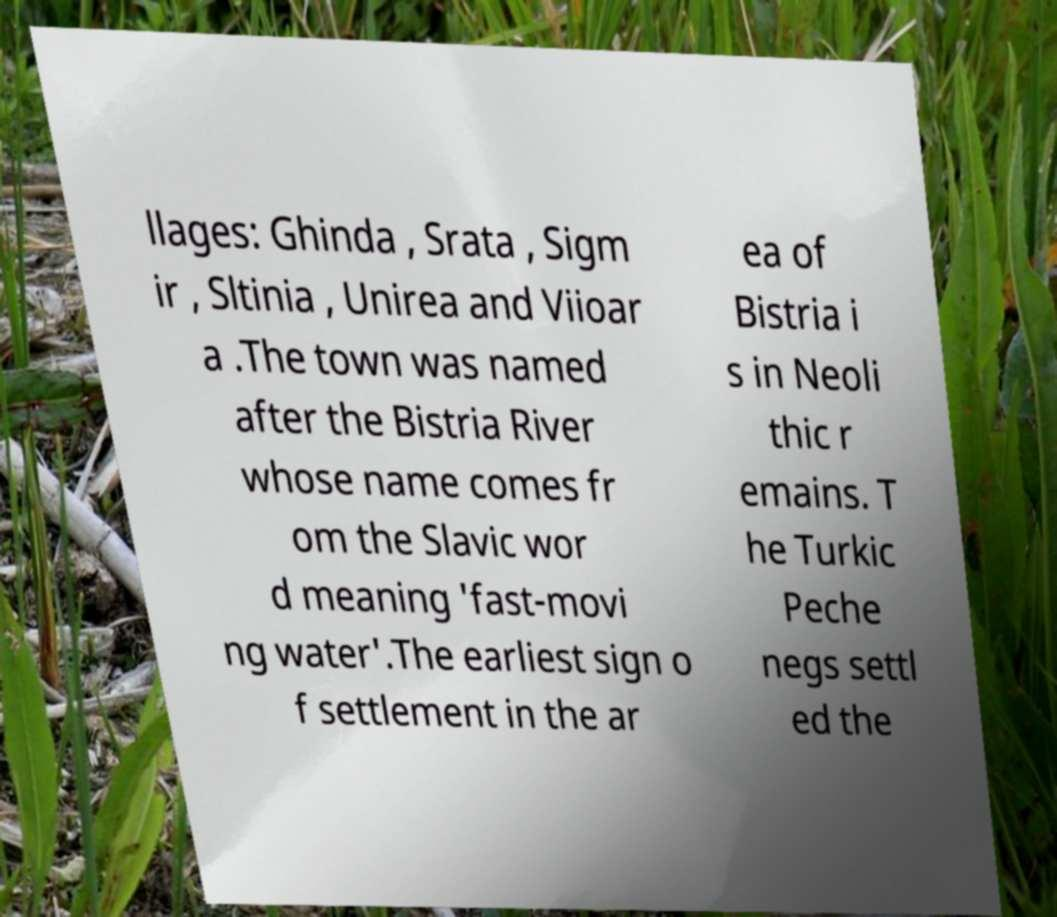There's text embedded in this image that I need extracted. Can you transcribe it verbatim? llages: Ghinda , Srata , Sigm ir , Sltinia , Unirea and Viioar a .The town was named after the Bistria River whose name comes fr om the Slavic wor d meaning 'fast-movi ng water'.The earliest sign o f settlement in the ar ea of Bistria i s in Neoli thic r emains. T he Turkic Peche negs settl ed the 